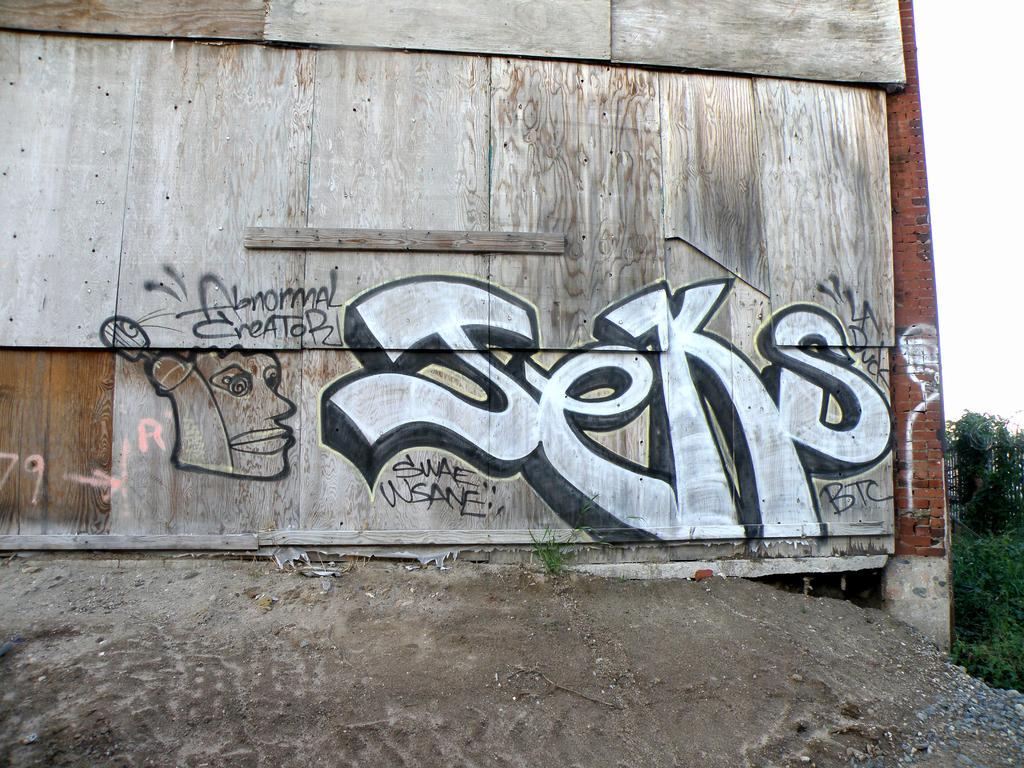What is depicted on the wooden wall in the image? There is graffiti on a wooden wall in the image. What type of vegetation can be seen on the right side of the image? There are trees on the right side of the image. What is visible in the background of the image? The sky is visible and clear in the image. What type of vegetable is growing on the wooden wall in the image? There are no vegetables growing on the wooden wall in the image; it features graffiti instead. 